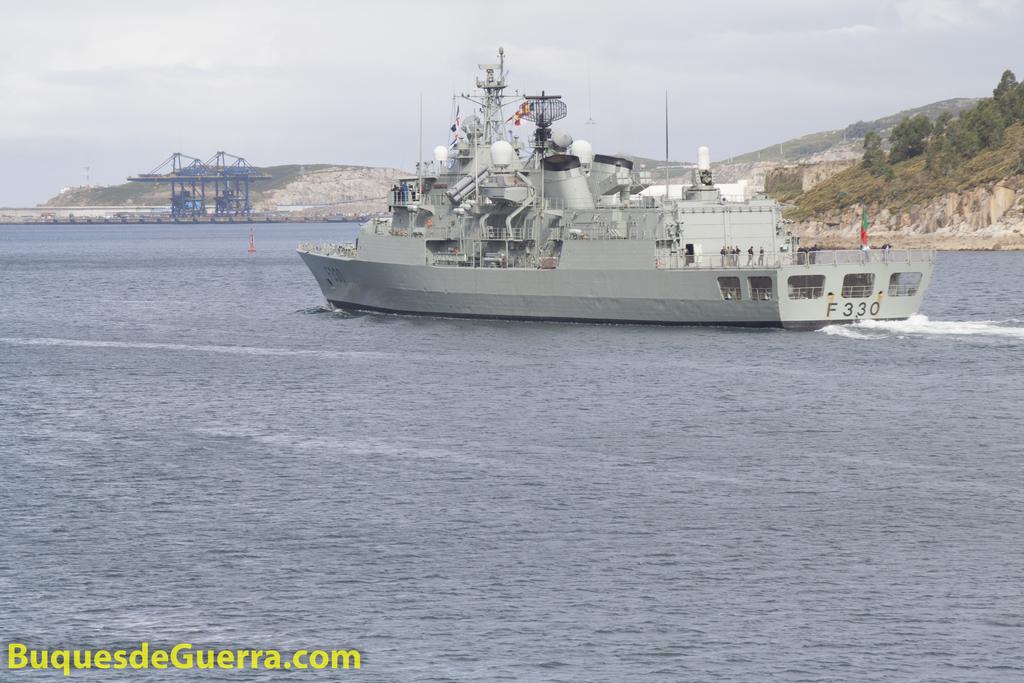What number is the boat?
Give a very brief answer. 330. What site is this from?
Your answer should be very brief. Buquesdeguerra.com. 